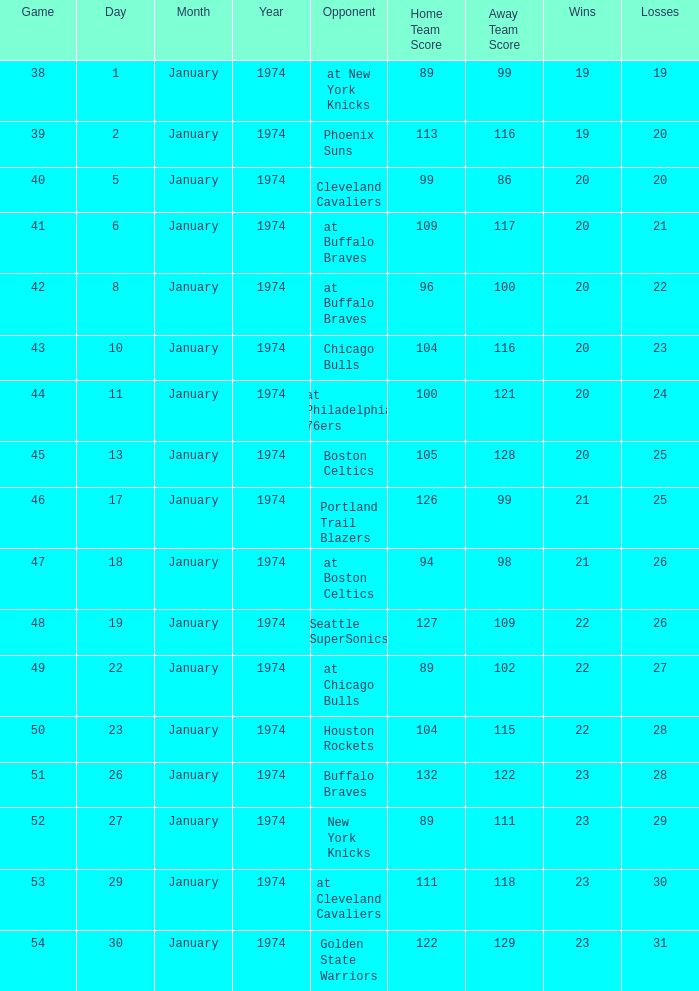What opponent played on 1/13/1974? Boston Celtics. 